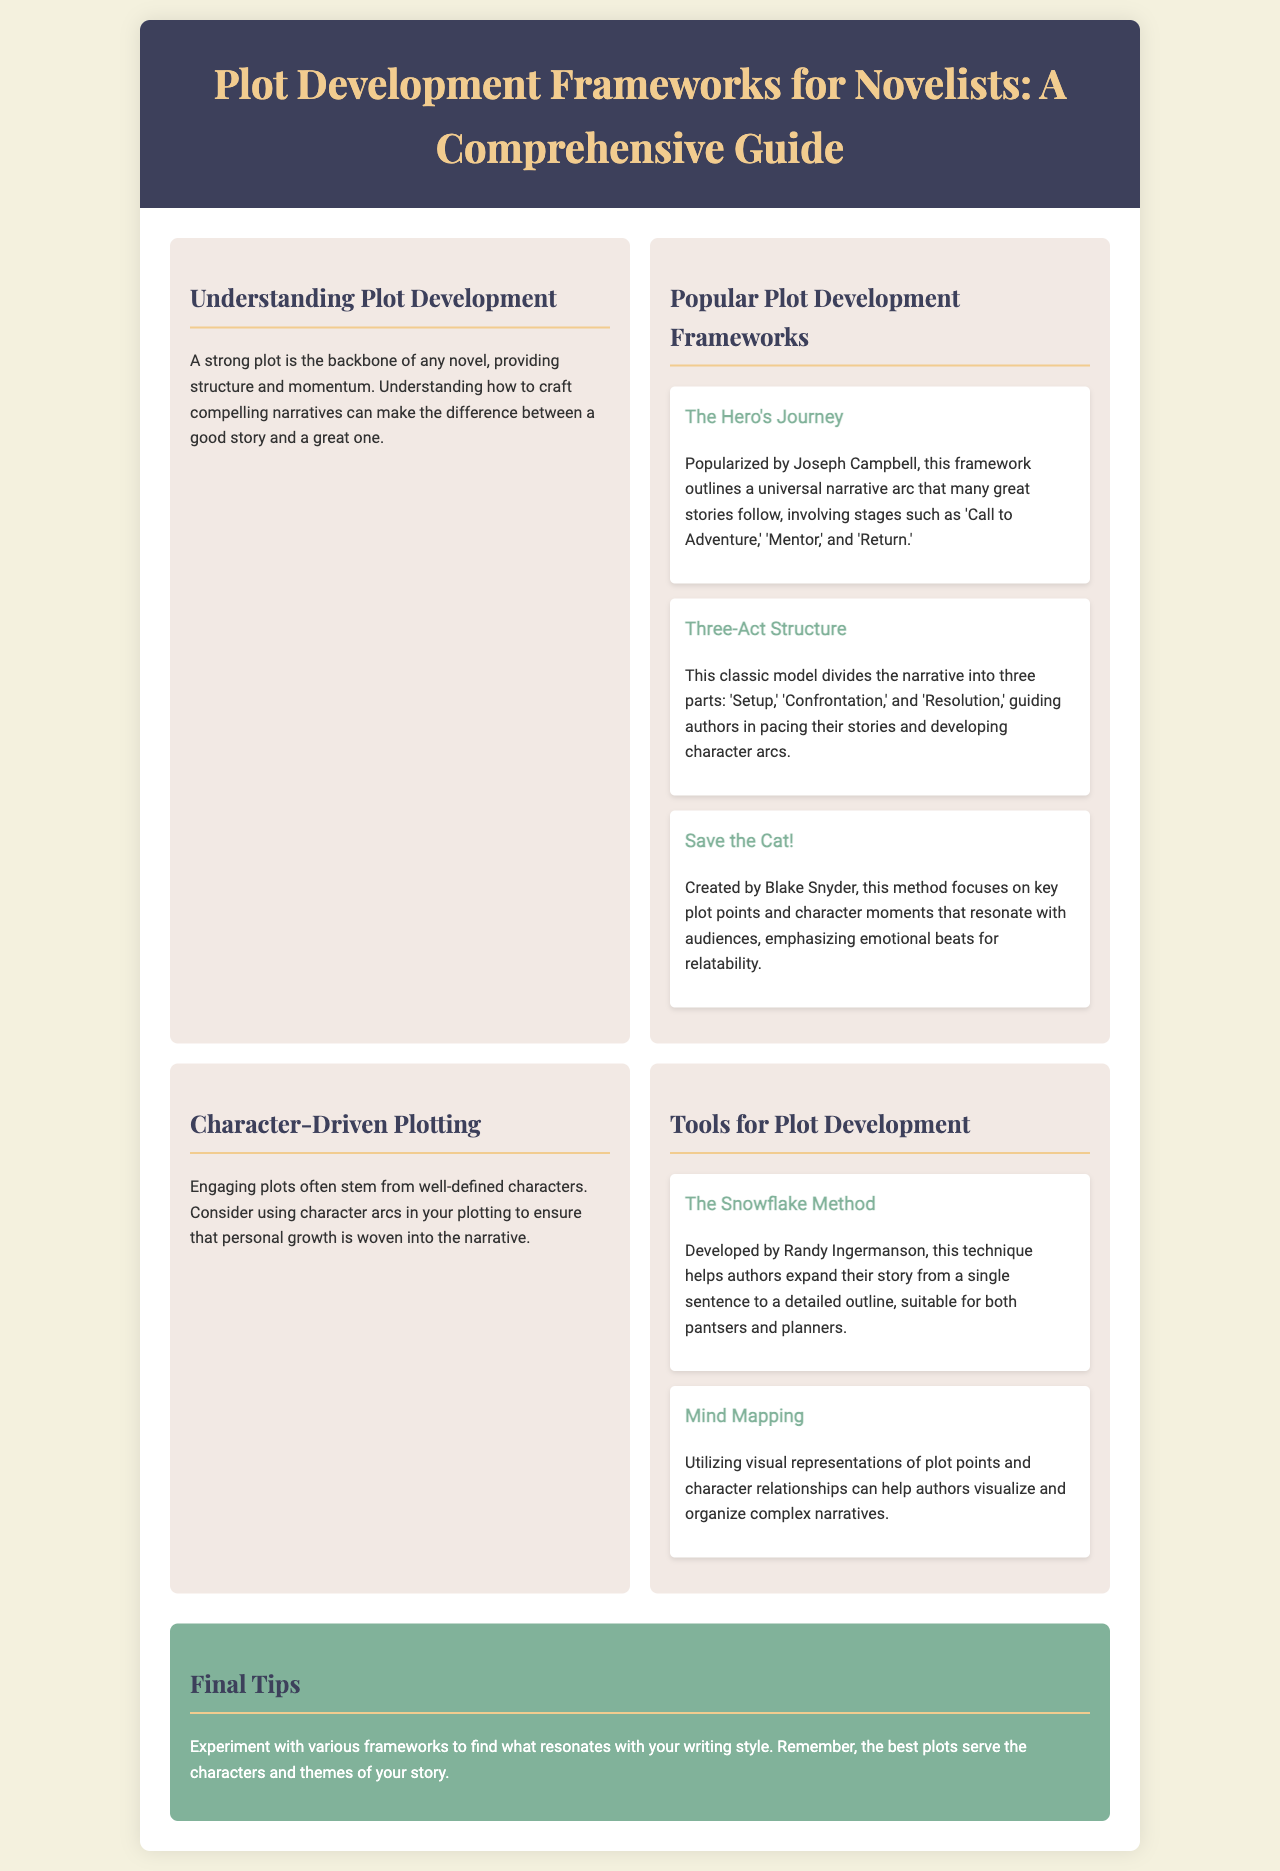what is the title of the brochure? The title is prominently displayed in the header section of the document.
Answer: Plot Development Frameworks for Novelists: A Comprehensive Guide who popularized The Hero's Journey framework? The document credits Joseph Campbell with popularizing this plot development framework.
Answer: Joseph Campbell how many popular plot development frameworks are mentioned? The document lists three popular frameworks under the corresponding section.
Answer: three what is the first step in the Three-Act Structure? This structure divides the narrative into three parts as mentioned in the document.
Answer: Setup who developed The Snowflake Method? The document specifies the author of this plot development tool.
Answer: Randy Ingermanson what is a focus of the Save the Cat! method? The document describes the emphasis of this method regarding plot points.
Answer: emotional beats what should plots serve according to the final tips? This guidance appears towards the end of the brochure, suggesting the role of plots in storytelling.
Answer: characters and themes what style of writing does the Snowflake Method accommodate? The document describes which types of writers the method is suitable for.
Answer: both pantsers and planners 